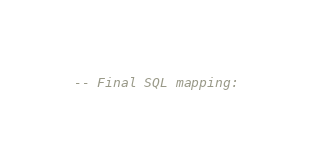<code> <loc_0><loc_0><loc_500><loc_500><_SQL_>-- Final SQL mapping: </code> 